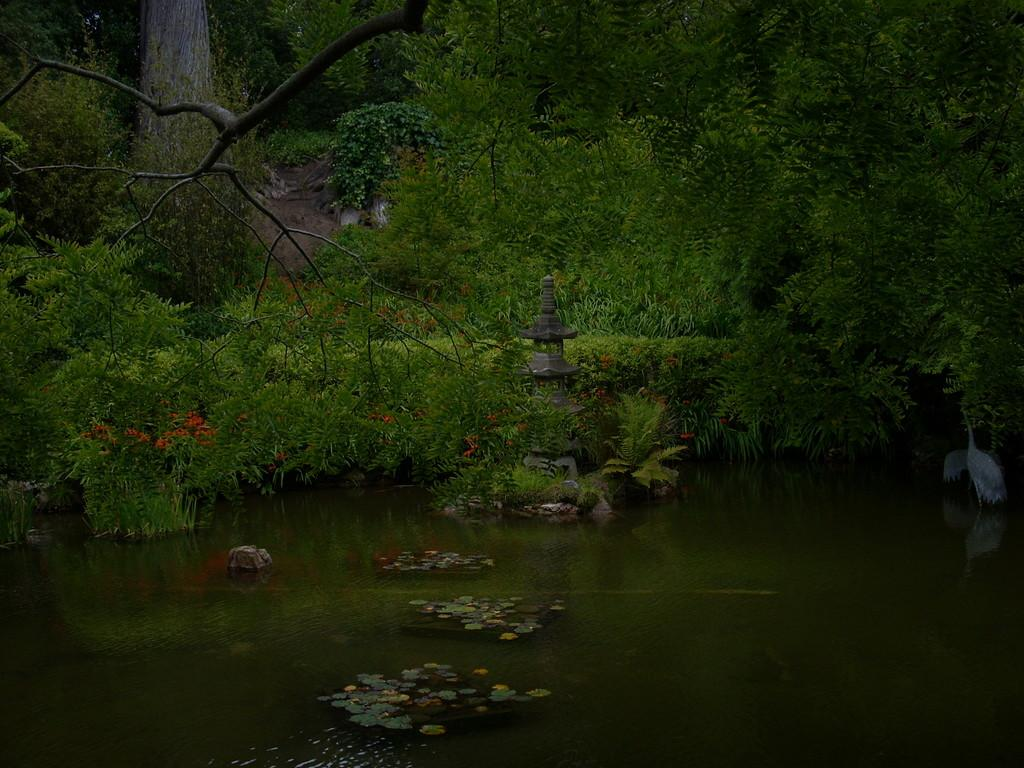What is the primary element in the image? There is water in the image. What can be found within the water? There are plants in the water. Where are the birds located in the image? There are two birds on the right side of the image. What architectural feature is present in the image? There is a pillar in the image. What type of vegetation can be seen in the background of the image? There are trees and flowers in the background of the image. What shape is the pen taking in the image? There is no pen present in the image. Is there a volcano visible in the image? No, there is no volcano in the image. 